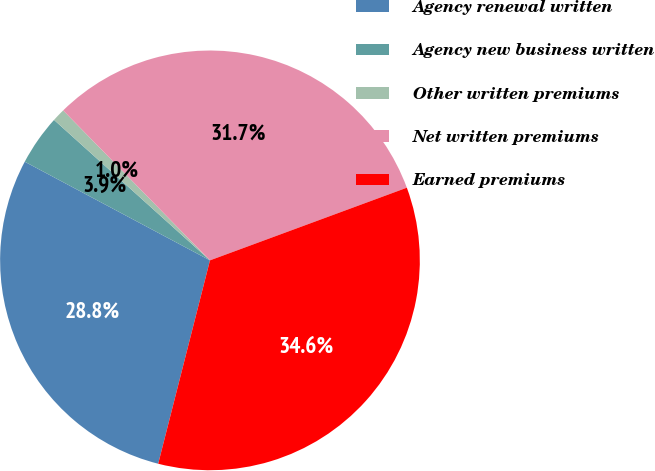<chart> <loc_0><loc_0><loc_500><loc_500><pie_chart><fcel>Agency renewal written<fcel>Agency new business written<fcel>Other written premiums<fcel>Net written premiums<fcel>Earned premiums<nl><fcel>28.82%<fcel>3.88%<fcel>1.0%<fcel>31.7%<fcel>34.59%<nl></chart> 